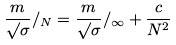<formula> <loc_0><loc_0><loc_500><loc_500>\frac { m } { \surd \sigma } / _ { N } = \frac { m } { \surd \sigma } / _ { \infty } + \frac { c } { N ^ { 2 } }</formula> 